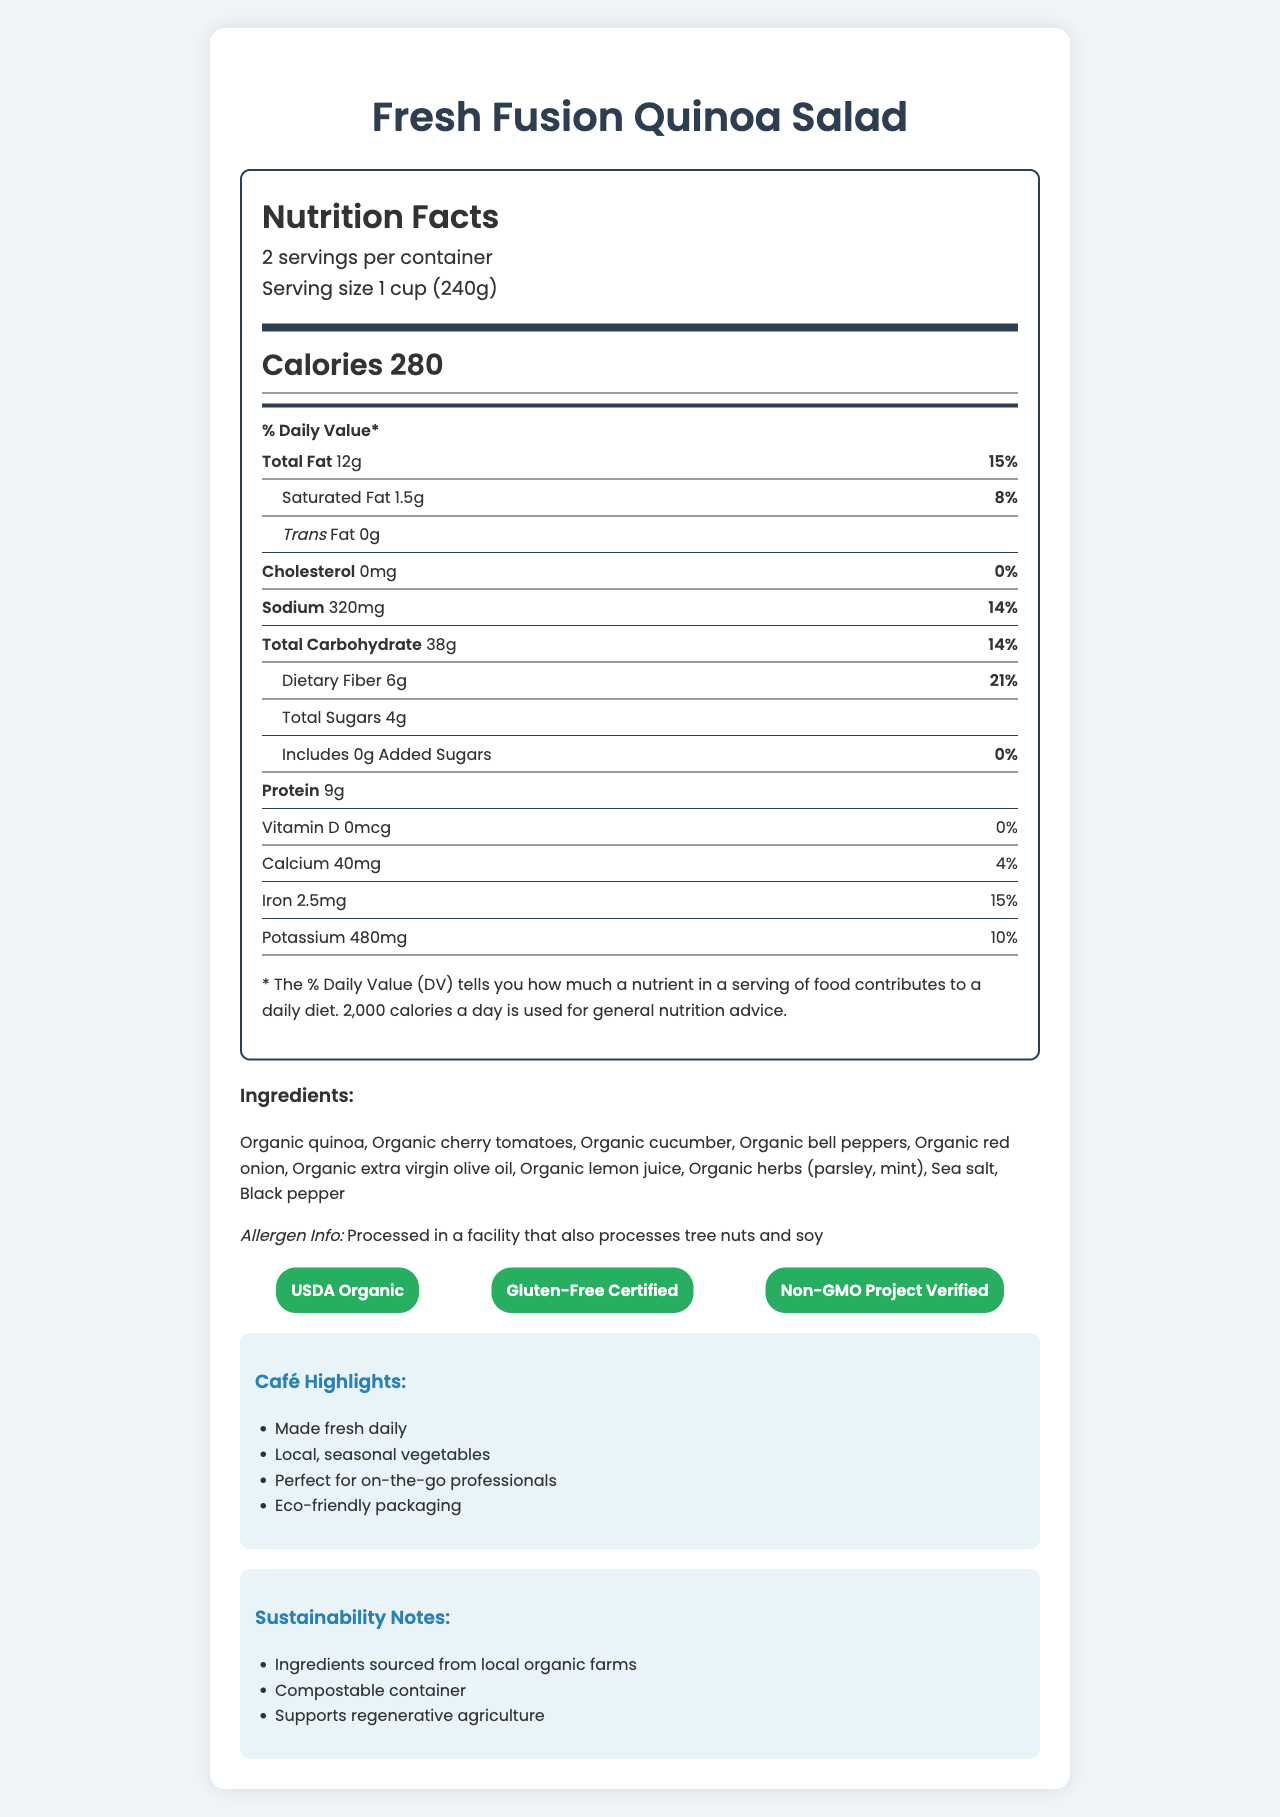what is the serving size? The serving size is mentioned under the nutrition header and states "Serving size 1 cup (240g)".
Answer: 1 cup (240g) how many calories are there per serving? The document states "Calories 280" right after the serving size information.
Answer: 280 what are the main ingredients in Fresh Fusion Quinoa Salad? This is listed under the "Ingredients" section of the document.
Answer: Organic quinoa, Organic cherry tomatoes, Organic cucumber, Organic bell peppers, Organic red onion, Organic extra virgin olive oil, Organic lemon juice, Organic herbs (parsley, mint), Sea salt, Black pepper how much protein is in one serving? The document lists "Protein 9g" under the daily value section.
Answer: 9g what certifications does this product have? The "Certifications" section at the bottom of the document lists the displayed certifications.
Answer: USDA Organic, Gluten-Free Certified, Non-GMO Project Verified what percentage of daily iron does one serving provide? The document lists "Iron 2.5mg" and "15%" under the daily value section.
Answer: 15% what is the total fat content per serving? The "Total Fat" amount is provided as "12g" with a daily value of 15%.
Answer: 12g which of the following is true about the quinoa salad? A. It contains dairy B. It has locally sourced ingredients C. It includes added sugars D. It is processed in a gluten facility The document highlights "Local, seasonal vegetables" under Café Highlights and confirms B as the correct answer.
Answer: B how many servings are there per container? The document mentions "2 servings per container" in the nutrition header section.
Answer: 2 does the product contain any added sugars? The information listed states, "Includes 0g Added Sugars," with a daily value of 0%.
Answer: No which of the following sustainability practices does the product support? I. Using compostable containers II. Sourcing ingredients from local farms III. Using plastic packaging The document mentions "Compostable container" and "Ingredients sourced from local organic farms" under Sustainability Notes.
Answer: I and II can the vitamin D content in this product be determined? The document lists "Vitamin D 0mcg" and "0%" showing no vitamin D content.
Answer: No summarize the main highlights of the Fresh Fusion Quinoa Salad. The summary covers the main nutritional information, ingredients, certifications, and sustainability practices of the product as detailed in the document.
Answer: Fresh Fusion Quinoa Salad is a gluten-free, organic quinoa salad with seasonal vegetables. It has 280 calories per serving and includes 12g of total fat, 6g of dietary fiber, and 9g of protein. The salad contains no cholesterol or trans fat and is certified USDA Organic, Gluten-Free, and Non-GMO. Ingredients are locally sourced, and eco-friendly practices are emphasized, such as using compostable containers and supporting regenerative agriculture. 